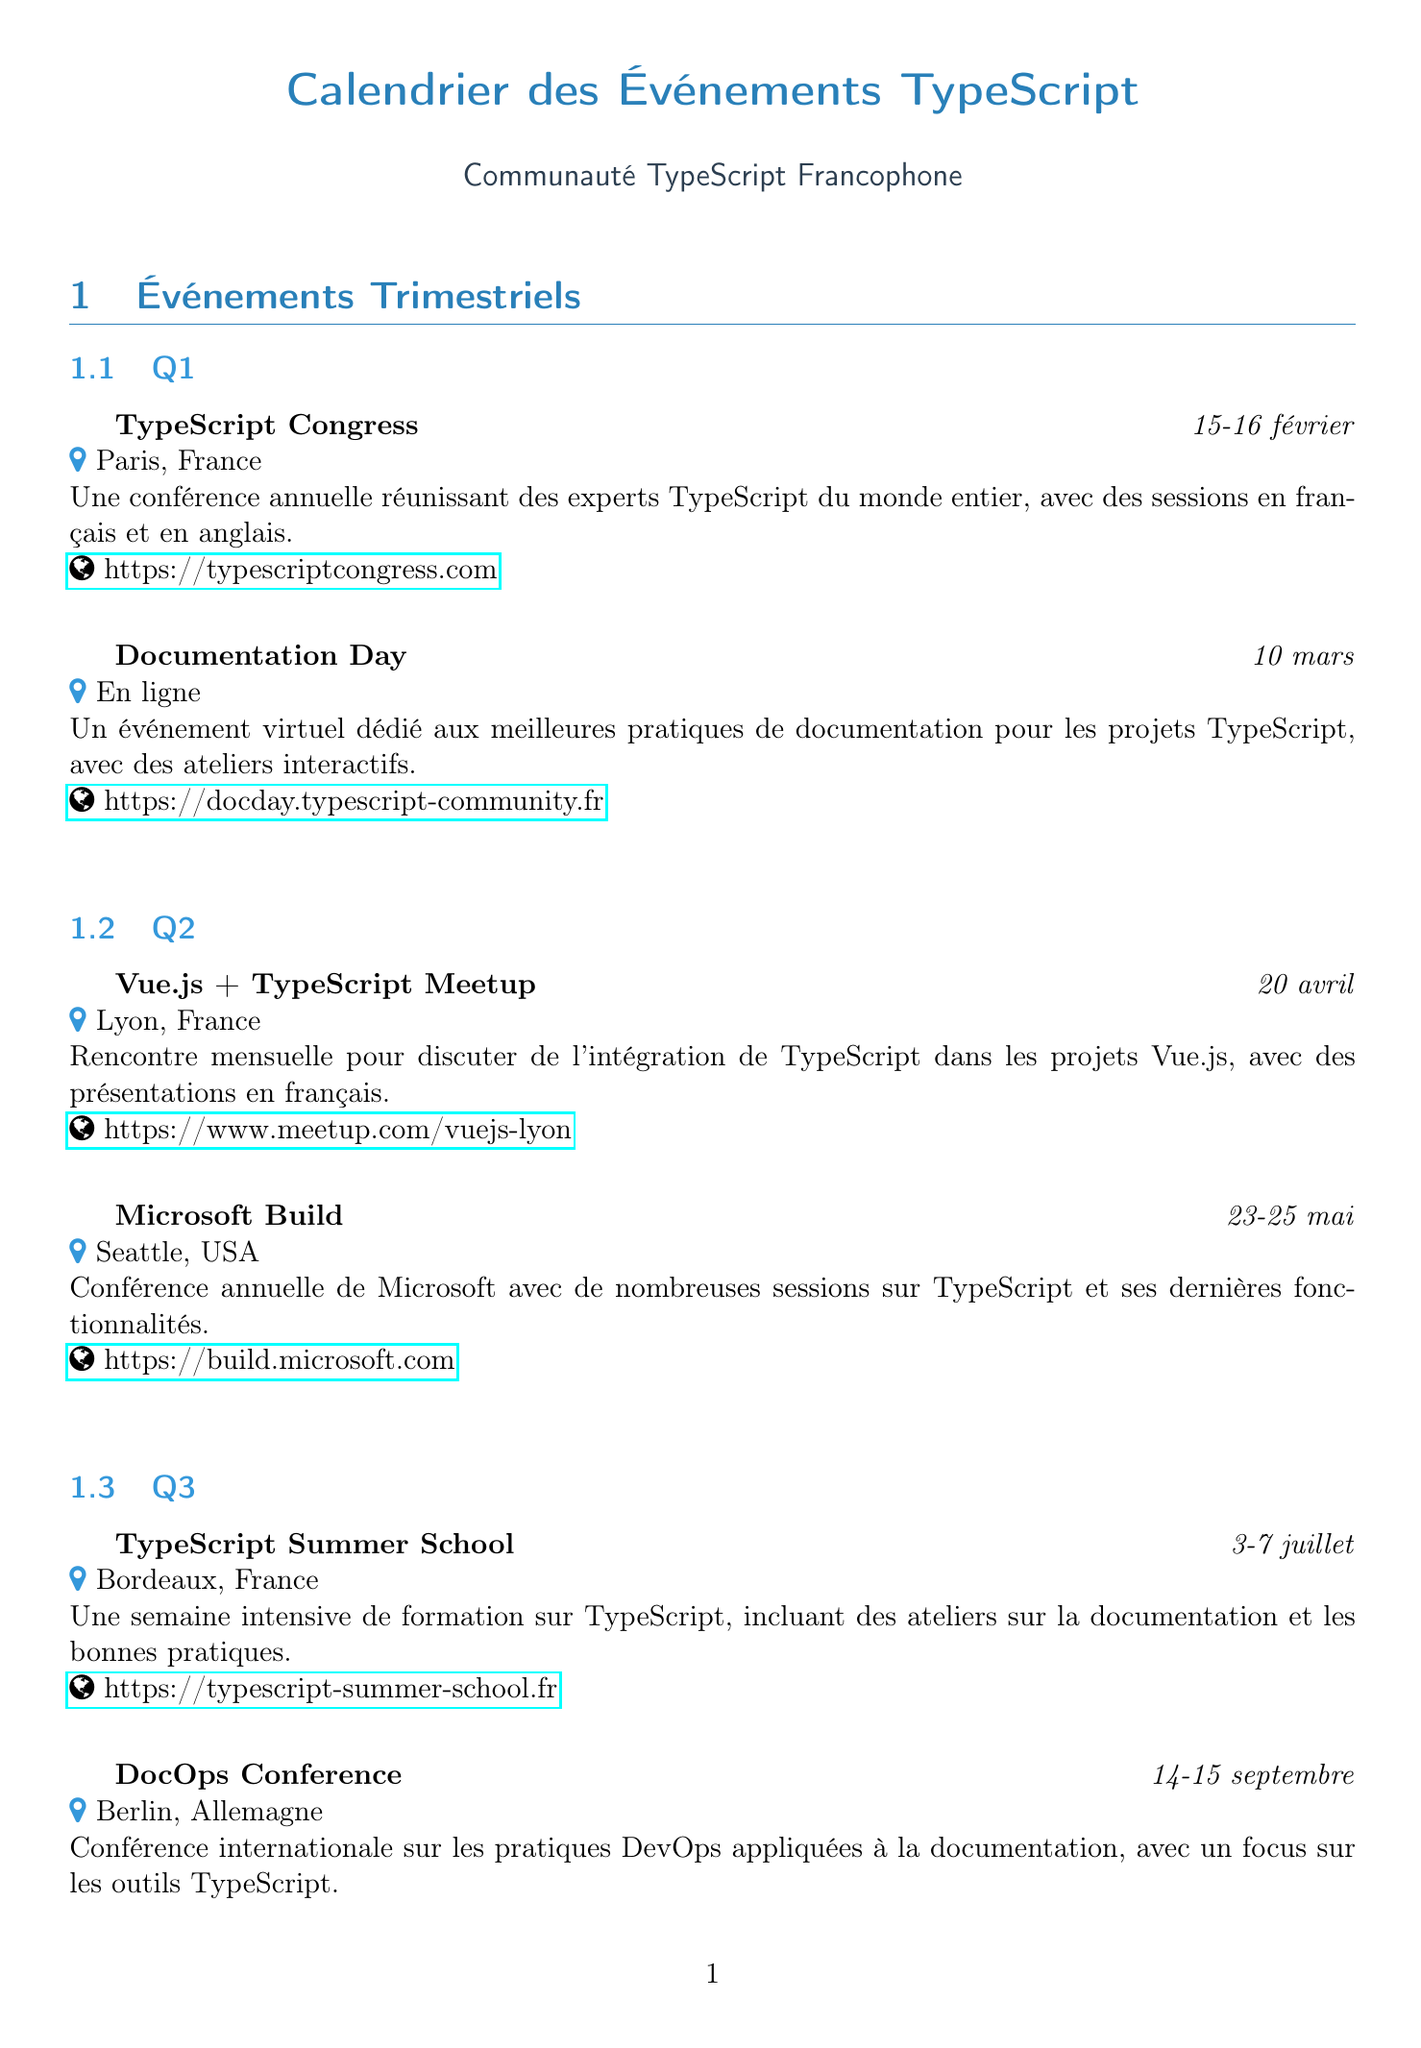What is the date of the TypeScript Congress? The date is explicitly stated in the document under Q1, which is February 15-16.
Answer: February 15-16 Where is the Documentation Day located? The location is mentioned in the description of the event in Q1, which states it is an online event.
Answer: Online What is the primary focus of the DocOps Conference? The document describes the focus of the conference, highlighting the practices DevOps applied to documentation, specifically regarding TypeScript tools.
Answer: Outils TypeScript How many events are listed in Q4? The total number of events in Q4 can be counted directly from the document, which shows two events.
Answer: 2 What type of activities does the French TypeScript Discord provide? The document mentions that it is a community Discord for developers focusing on documentation and best practices.
Answer: Documentation et bonnes pratiques Which month is the TypeScript Summer School held? The document specifies that the TypeScript Summer School takes place in July.
Answer: Juillet How often is the TypeScript Paris Meetup held? The frequency of this meetup is detailed in the ongoing community activities section, indicating that it is a monthly event.
Answer: Mensuel What is the name of the newsletter mentioned in the document? The document lists the newsletter title directly as TypeScript Weekly FR in the ongoing community activities section.
Answer: TypeScript Weekly FR 